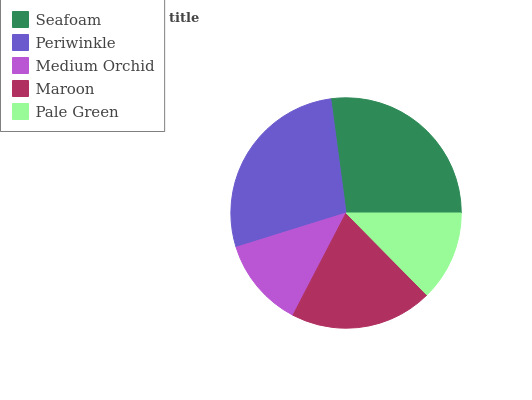Is Medium Orchid the minimum?
Answer yes or no. Yes. Is Periwinkle the maximum?
Answer yes or no. Yes. Is Periwinkle the minimum?
Answer yes or no. No. Is Medium Orchid the maximum?
Answer yes or no. No. Is Periwinkle greater than Medium Orchid?
Answer yes or no. Yes. Is Medium Orchid less than Periwinkle?
Answer yes or no. Yes. Is Medium Orchid greater than Periwinkle?
Answer yes or no. No. Is Periwinkle less than Medium Orchid?
Answer yes or no. No. Is Maroon the high median?
Answer yes or no. Yes. Is Maroon the low median?
Answer yes or no. Yes. Is Medium Orchid the high median?
Answer yes or no. No. Is Pale Green the low median?
Answer yes or no. No. 